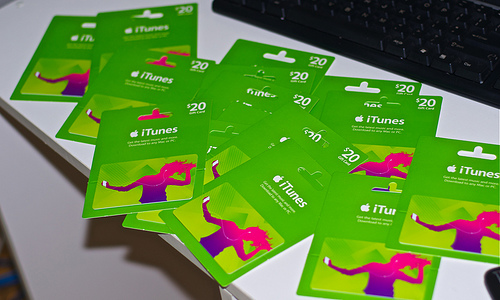<image>
Is there a gift cards behind the keyboard? No. The gift cards is not behind the keyboard. From this viewpoint, the gift cards appears to be positioned elsewhere in the scene. 